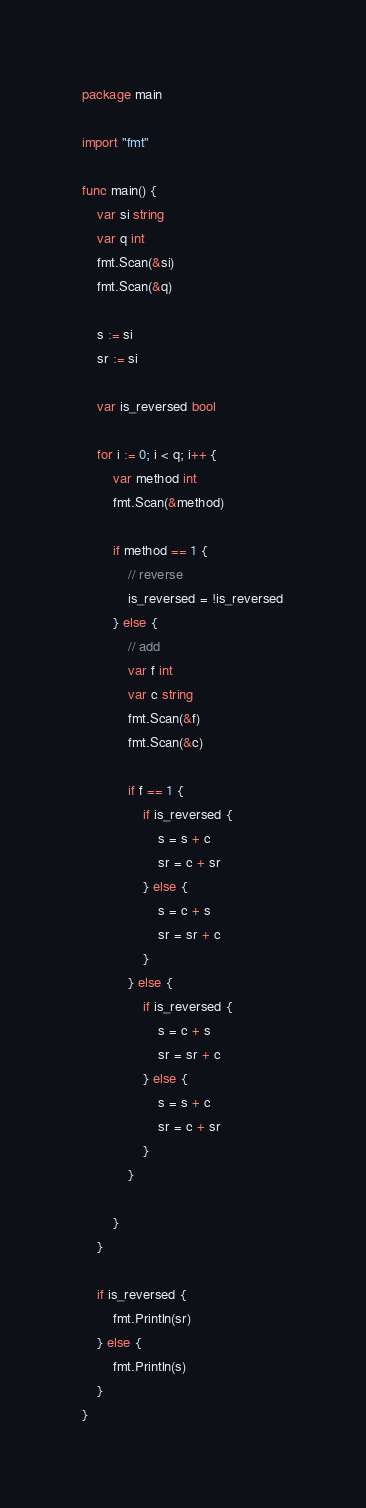Convert code to text. <code><loc_0><loc_0><loc_500><loc_500><_Go_>package main

import "fmt"

func main() {
	var si string
	var q int
	fmt.Scan(&si)
	fmt.Scan(&q)

	s := si
	sr := si

	var is_reversed bool

	for i := 0; i < q; i++ {
		var method int
		fmt.Scan(&method)

		if method == 1 {
			// reverse 
			is_reversed = !is_reversed
		} else {
			// add 
			var f int
			var c string
			fmt.Scan(&f)
			fmt.Scan(&c)

			if f == 1 {
				if is_reversed {
					s = s + c
					sr = c + sr
				} else {
					s = c + s
					sr = sr + c
				}
			} else {
				if is_reversed {
					s = c + s
					sr = sr + c
				} else {
					s = s + c
					sr = c + sr
				}
			}

		}
	}

	if is_reversed {
		fmt.Println(sr)
	} else {
		fmt.Println(s)
	}
}
</code> 